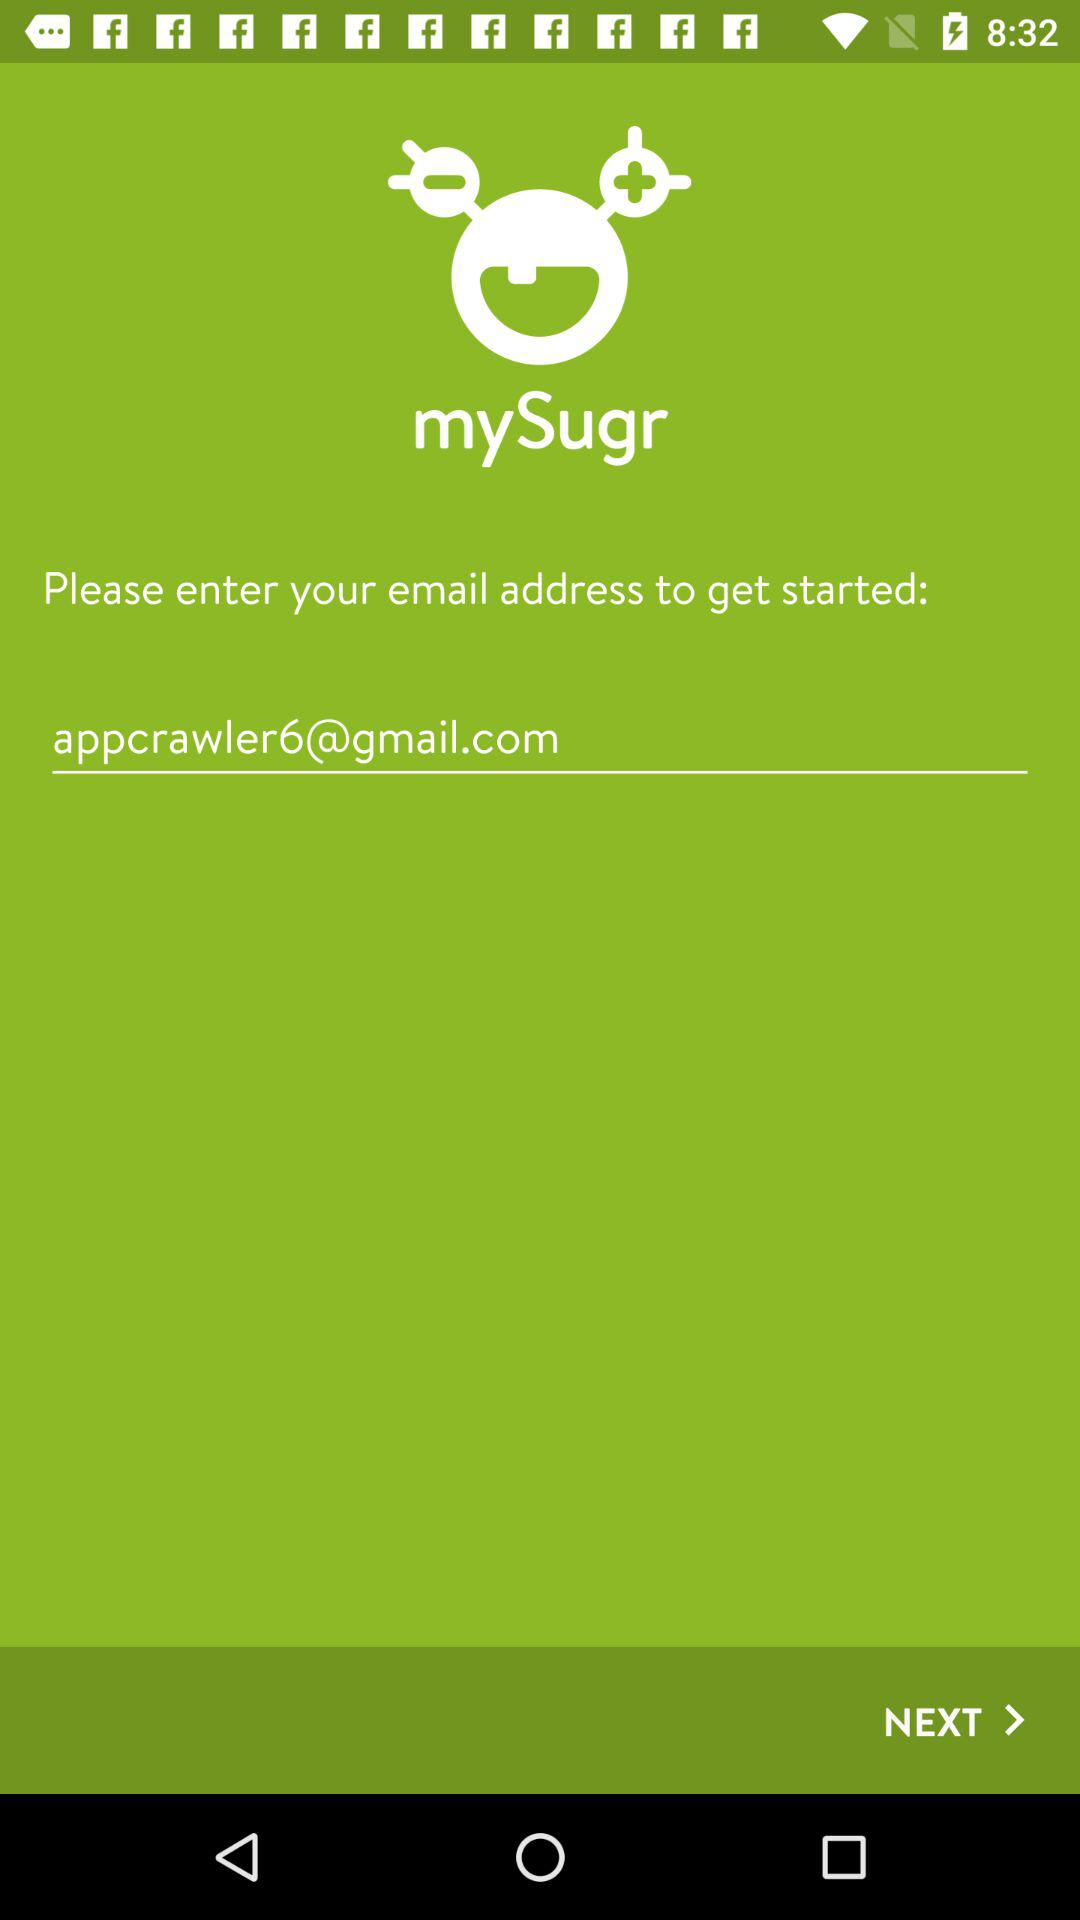What's the Google Mail address? The Google Mail address is appcrawler6@gmail.com. 